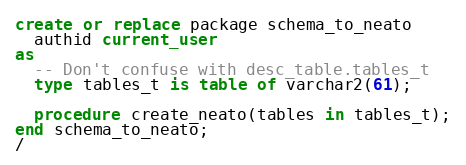<code> <loc_0><loc_0><loc_500><loc_500><_SQL_>
create or replace package schema_to_neato
  authid current_user
as 
  -- Don't confuse with desc_table.tables_t
  type tables_t is table of varchar2(61);

  procedure create_neato(tables in tables_t);
end schema_to_neato;
/
</code> 